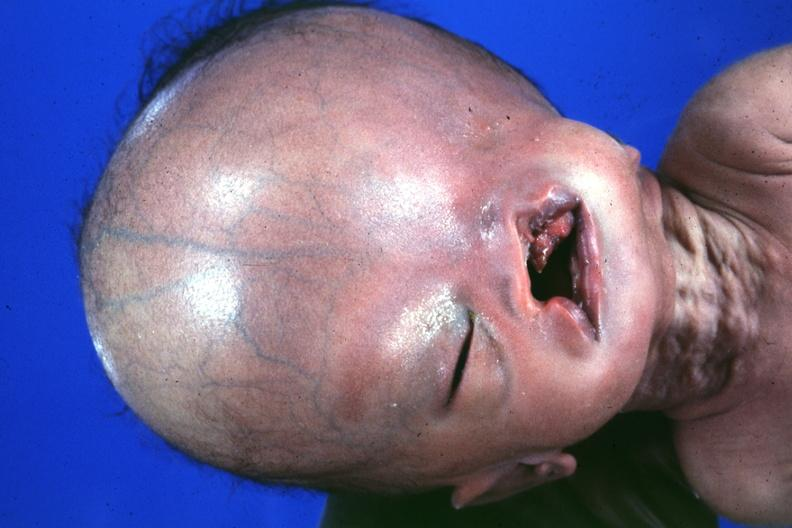s complex craniofacial abnormalities present?
Answer the question using a single word or phrase. Yes 